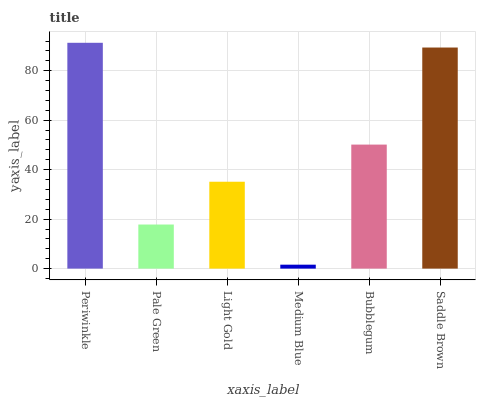Is Pale Green the minimum?
Answer yes or no. No. Is Pale Green the maximum?
Answer yes or no. No. Is Periwinkle greater than Pale Green?
Answer yes or no. Yes. Is Pale Green less than Periwinkle?
Answer yes or no. Yes. Is Pale Green greater than Periwinkle?
Answer yes or no. No. Is Periwinkle less than Pale Green?
Answer yes or no. No. Is Bubblegum the high median?
Answer yes or no. Yes. Is Light Gold the low median?
Answer yes or no. Yes. Is Light Gold the high median?
Answer yes or no. No. Is Periwinkle the low median?
Answer yes or no. No. 